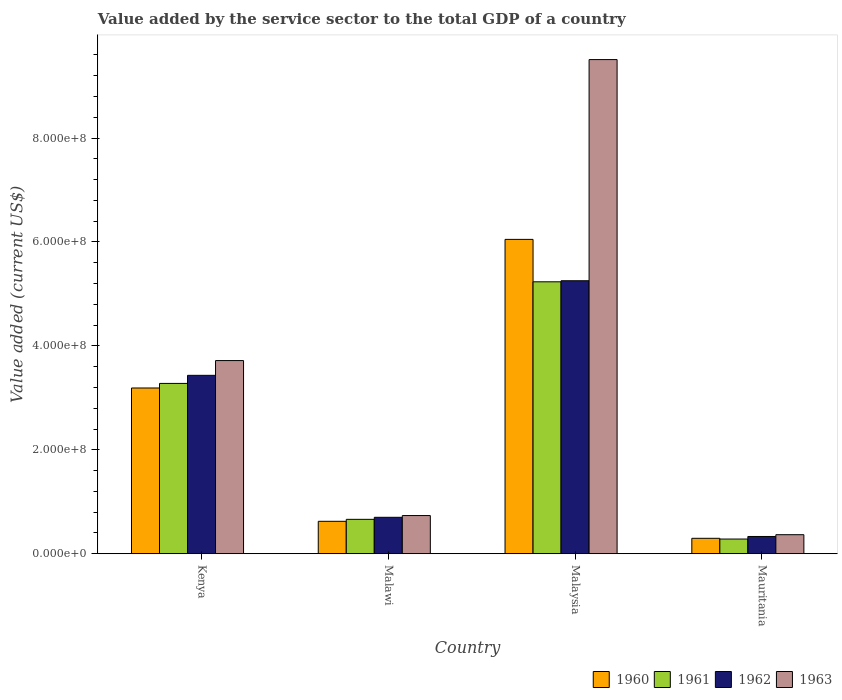How many groups of bars are there?
Your answer should be compact. 4. What is the label of the 3rd group of bars from the left?
Keep it short and to the point. Malaysia. In how many cases, is the number of bars for a given country not equal to the number of legend labels?
Provide a short and direct response. 0. What is the value added by the service sector to the total GDP in 1960 in Kenya?
Offer a terse response. 3.19e+08. Across all countries, what is the maximum value added by the service sector to the total GDP in 1961?
Your response must be concise. 5.23e+08. Across all countries, what is the minimum value added by the service sector to the total GDP in 1963?
Provide a short and direct response. 3.67e+07. In which country was the value added by the service sector to the total GDP in 1963 maximum?
Keep it short and to the point. Malaysia. In which country was the value added by the service sector to the total GDP in 1962 minimum?
Offer a terse response. Mauritania. What is the total value added by the service sector to the total GDP in 1963 in the graph?
Keep it short and to the point. 1.43e+09. What is the difference between the value added by the service sector to the total GDP in 1961 in Malawi and that in Mauritania?
Provide a short and direct response. 3.79e+07. What is the difference between the value added by the service sector to the total GDP in 1963 in Malawi and the value added by the service sector to the total GDP in 1960 in Kenya?
Provide a succinct answer. -2.46e+08. What is the average value added by the service sector to the total GDP in 1962 per country?
Offer a very short reply. 2.43e+08. What is the difference between the value added by the service sector to the total GDP of/in 1961 and value added by the service sector to the total GDP of/in 1960 in Malawi?
Provide a short and direct response. 3.78e+06. What is the ratio of the value added by the service sector to the total GDP in 1963 in Kenya to that in Malaysia?
Provide a short and direct response. 0.39. Is the difference between the value added by the service sector to the total GDP in 1961 in Kenya and Malawi greater than the difference between the value added by the service sector to the total GDP in 1960 in Kenya and Malawi?
Make the answer very short. Yes. What is the difference between the highest and the second highest value added by the service sector to the total GDP in 1963?
Provide a short and direct response. 5.79e+08. What is the difference between the highest and the lowest value added by the service sector to the total GDP in 1963?
Offer a very short reply. 9.14e+08. In how many countries, is the value added by the service sector to the total GDP in 1962 greater than the average value added by the service sector to the total GDP in 1962 taken over all countries?
Offer a terse response. 2. Is the sum of the value added by the service sector to the total GDP in 1961 in Malawi and Malaysia greater than the maximum value added by the service sector to the total GDP in 1963 across all countries?
Offer a terse response. No. Is it the case that in every country, the sum of the value added by the service sector to the total GDP in 1962 and value added by the service sector to the total GDP in 1960 is greater than the sum of value added by the service sector to the total GDP in 1961 and value added by the service sector to the total GDP in 1963?
Provide a short and direct response. No. What does the 2nd bar from the right in Mauritania represents?
Keep it short and to the point. 1962. Is it the case that in every country, the sum of the value added by the service sector to the total GDP in 1960 and value added by the service sector to the total GDP in 1962 is greater than the value added by the service sector to the total GDP in 1961?
Provide a short and direct response. Yes. What is the difference between two consecutive major ticks on the Y-axis?
Your response must be concise. 2.00e+08. Are the values on the major ticks of Y-axis written in scientific E-notation?
Give a very brief answer. Yes. How many legend labels are there?
Your answer should be very brief. 4. How are the legend labels stacked?
Make the answer very short. Horizontal. What is the title of the graph?
Your response must be concise. Value added by the service sector to the total GDP of a country. Does "2014" appear as one of the legend labels in the graph?
Your response must be concise. No. What is the label or title of the Y-axis?
Ensure brevity in your answer.  Value added (current US$). What is the Value added (current US$) of 1960 in Kenya?
Give a very brief answer. 3.19e+08. What is the Value added (current US$) in 1961 in Kenya?
Provide a short and direct response. 3.28e+08. What is the Value added (current US$) in 1962 in Kenya?
Ensure brevity in your answer.  3.43e+08. What is the Value added (current US$) in 1963 in Kenya?
Your response must be concise. 3.72e+08. What is the Value added (current US$) of 1960 in Malawi?
Offer a very short reply. 6.24e+07. What is the Value added (current US$) in 1961 in Malawi?
Ensure brevity in your answer.  6.62e+07. What is the Value added (current US$) of 1962 in Malawi?
Make the answer very short. 7.01e+07. What is the Value added (current US$) in 1963 in Malawi?
Ensure brevity in your answer.  7.35e+07. What is the Value added (current US$) in 1960 in Malaysia?
Make the answer very short. 6.05e+08. What is the Value added (current US$) of 1961 in Malaysia?
Your answer should be compact. 5.23e+08. What is the Value added (current US$) of 1962 in Malaysia?
Make the answer very short. 5.25e+08. What is the Value added (current US$) in 1963 in Malaysia?
Provide a succinct answer. 9.51e+08. What is the Value added (current US$) in 1960 in Mauritania?
Keep it short and to the point. 2.97e+07. What is the Value added (current US$) in 1961 in Mauritania?
Give a very brief answer. 2.83e+07. What is the Value added (current US$) in 1962 in Mauritania?
Provide a succinct answer. 3.32e+07. What is the Value added (current US$) in 1963 in Mauritania?
Give a very brief answer. 3.67e+07. Across all countries, what is the maximum Value added (current US$) of 1960?
Your answer should be compact. 6.05e+08. Across all countries, what is the maximum Value added (current US$) of 1961?
Make the answer very short. 5.23e+08. Across all countries, what is the maximum Value added (current US$) of 1962?
Offer a terse response. 5.25e+08. Across all countries, what is the maximum Value added (current US$) in 1963?
Make the answer very short. 9.51e+08. Across all countries, what is the minimum Value added (current US$) of 1960?
Your response must be concise. 2.97e+07. Across all countries, what is the minimum Value added (current US$) of 1961?
Your answer should be compact. 2.83e+07. Across all countries, what is the minimum Value added (current US$) in 1962?
Provide a succinct answer. 3.32e+07. Across all countries, what is the minimum Value added (current US$) in 1963?
Your response must be concise. 3.67e+07. What is the total Value added (current US$) of 1960 in the graph?
Provide a short and direct response. 1.02e+09. What is the total Value added (current US$) in 1961 in the graph?
Make the answer very short. 9.46e+08. What is the total Value added (current US$) in 1962 in the graph?
Offer a very short reply. 9.72e+08. What is the total Value added (current US$) of 1963 in the graph?
Keep it short and to the point. 1.43e+09. What is the difference between the Value added (current US$) of 1960 in Kenya and that in Malawi?
Provide a short and direct response. 2.57e+08. What is the difference between the Value added (current US$) of 1961 in Kenya and that in Malawi?
Provide a succinct answer. 2.62e+08. What is the difference between the Value added (current US$) of 1962 in Kenya and that in Malawi?
Provide a short and direct response. 2.73e+08. What is the difference between the Value added (current US$) in 1963 in Kenya and that in Malawi?
Provide a short and direct response. 2.98e+08. What is the difference between the Value added (current US$) in 1960 in Kenya and that in Malaysia?
Make the answer very short. -2.86e+08. What is the difference between the Value added (current US$) of 1961 in Kenya and that in Malaysia?
Offer a terse response. -1.96e+08. What is the difference between the Value added (current US$) in 1962 in Kenya and that in Malaysia?
Ensure brevity in your answer.  -1.82e+08. What is the difference between the Value added (current US$) of 1963 in Kenya and that in Malaysia?
Ensure brevity in your answer.  -5.79e+08. What is the difference between the Value added (current US$) of 1960 in Kenya and that in Mauritania?
Ensure brevity in your answer.  2.89e+08. What is the difference between the Value added (current US$) of 1961 in Kenya and that in Mauritania?
Your response must be concise. 3.00e+08. What is the difference between the Value added (current US$) in 1962 in Kenya and that in Mauritania?
Your answer should be very brief. 3.10e+08. What is the difference between the Value added (current US$) in 1963 in Kenya and that in Mauritania?
Give a very brief answer. 3.35e+08. What is the difference between the Value added (current US$) in 1960 in Malawi and that in Malaysia?
Give a very brief answer. -5.43e+08. What is the difference between the Value added (current US$) of 1961 in Malawi and that in Malaysia?
Make the answer very short. -4.57e+08. What is the difference between the Value added (current US$) of 1962 in Malawi and that in Malaysia?
Provide a short and direct response. -4.55e+08. What is the difference between the Value added (current US$) in 1963 in Malawi and that in Malaysia?
Your answer should be compact. -8.78e+08. What is the difference between the Value added (current US$) of 1960 in Malawi and that in Mauritania?
Keep it short and to the point. 3.27e+07. What is the difference between the Value added (current US$) in 1961 in Malawi and that in Mauritania?
Provide a succinct answer. 3.79e+07. What is the difference between the Value added (current US$) of 1962 in Malawi and that in Mauritania?
Your response must be concise. 3.69e+07. What is the difference between the Value added (current US$) in 1963 in Malawi and that in Mauritania?
Your answer should be compact. 3.68e+07. What is the difference between the Value added (current US$) in 1960 in Malaysia and that in Mauritania?
Give a very brief answer. 5.75e+08. What is the difference between the Value added (current US$) in 1961 in Malaysia and that in Mauritania?
Your answer should be compact. 4.95e+08. What is the difference between the Value added (current US$) of 1962 in Malaysia and that in Mauritania?
Your response must be concise. 4.92e+08. What is the difference between the Value added (current US$) in 1963 in Malaysia and that in Mauritania?
Keep it short and to the point. 9.14e+08. What is the difference between the Value added (current US$) in 1960 in Kenya and the Value added (current US$) in 1961 in Malawi?
Make the answer very short. 2.53e+08. What is the difference between the Value added (current US$) of 1960 in Kenya and the Value added (current US$) of 1962 in Malawi?
Provide a short and direct response. 2.49e+08. What is the difference between the Value added (current US$) of 1960 in Kenya and the Value added (current US$) of 1963 in Malawi?
Give a very brief answer. 2.46e+08. What is the difference between the Value added (current US$) in 1961 in Kenya and the Value added (current US$) in 1962 in Malawi?
Your answer should be very brief. 2.58e+08. What is the difference between the Value added (current US$) in 1961 in Kenya and the Value added (current US$) in 1963 in Malawi?
Make the answer very short. 2.54e+08. What is the difference between the Value added (current US$) in 1962 in Kenya and the Value added (current US$) in 1963 in Malawi?
Provide a succinct answer. 2.70e+08. What is the difference between the Value added (current US$) in 1960 in Kenya and the Value added (current US$) in 1961 in Malaysia?
Give a very brief answer. -2.04e+08. What is the difference between the Value added (current US$) of 1960 in Kenya and the Value added (current US$) of 1962 in Malaysia?
Provide a succinct answer. -2.06e+08. What is the difference between the Value added (current US$) of 1960 in Kenya and the Value added (current US$) of 1963 in Malaysia?
Give a very brief answer. -6.32e+08. What is the difference between the Value added (current US$) of 1961 in Kenya and the Value added (current US$) of 1962 in Malaysia?
Provide a short and direct response. -1.98e+08. What is the difference between the Value added (current US$) of 1961 in Kenya and the Value added (current US$) of 1963 in Malaysia?
Make the answer very short. -6.23e+08. What is the difference between the Value added (current US$) in 1962 in Kenya and the Value added (current US$) in 1963 in Malaysia?
Provide a short and direct response. -6.08e+08. What is the difference between the Value added (current US$) of 1960 in Kenya and the Value added (current US$) of 1961 in Mauritania?
Give a very brief answer. 2.91e+08. What is the difference between the Value added (current US$) in 1960 in Kenya and the Value added (current US$) in 1962 in Mauritania?
Keep it short and to the point. 2.86e+08. What is the difference between the Value added (current US$) of 1960 in Kenya and the Value added (current US$) of 1963 in Mauritania?
Your answer should be compact. 2.82e+08. What is the difference between the Value added (current US$) in 1961 in Kenya and the Value added (current US$) in 1962 in Mauritania?
Your answer should be compact. 2.95e+08. What is the difference between the Value added (current US$) in 1961 in Kenya and the Value added (current US$) in 1963 in Mauritania?
Keep it short and to the point. 2.91e+08. What is the difference between the Value added (current US$) of 1962 in Kenya and the Value added (current US$) of 1963 in Mauritania?
Ensure brevity in your answer.  3.07e+08. What is the difference between the Value added (current US$) of 1960 in Malawi and the Value added (current US$) of 1961 in Malaysia?
Provide a succinct answer. -4.61e+08. What is the difference between the Value added (current US$) in 1960 in Malawi and the Value added (current US$) in 1962 in Malaysia?
Provide a succinct answer. -4.63e+08. What is the difference between the Value added (current US$) in 1960 in Malawi and the Value added (current US$) in 1963 in Malaysia?
Provide a short and direct response. -8.89e+08. What is the difference between the Value added (current US$) of 1961 in Malawi and the Value added (current US$) of 1962 in Malaysia?
Offer a very short reply. -4.59e+08. What is the difference between the Value added (current US$) of 1961 in Malawi and the Value added (current US$) of 1963 in Malaysia?
Keep it short and to the point. -8.85e+08. What is the difference between the Value added (current US$) in 1962 in Malawi and the Value added (current US$) in 1963 in Malaysia?
Give a very brief answer. -8.81e+08. What is the difference between the Value added (current US$) in 1960 in Malawi and the Value added (current US$) in 1961 in Mauritania?
Provide a short and direct response. 3.41e+07. What is the difference between the Value added (current US$) of 1960 in Malawi and the Value added (current US$) of 1962 in Mauritania?
Keep it short and to the point. 2.92e+07. What is the difference between the Value added (current US$) of 1960 in Malawi and the Value added (current US$) of 1963 in Mauritania?
Offer a very short reply. 2.58e+07. What is the difference between the Value added (current US$) of 1961 in Malawi and the Value added (current US$) of 1962 in Mauritania?
Your answer should be very brief. 3.30e+07. What is the difference between the Value added (current US$) in 1961 in Malawi and the Value added (current US$) in 1963 in Mauritania?
Your answer should be compact. 2.96e+07. What is the difference between the Value added (current US$) in 1962 in Malawi and the Value added (current US$) in 1963 in Mauritania?
Provide a short and direct response. 3.35e+07. What is the difference between the Value added (current US$) in 1960 in Malaysia and the Value added (current US$) in 1961 in Mauritania?
Your answer should be very brief. 5.77e+08. What is the difference between the Value added (current US$) in 1960 in Malaysia and the Value added (current US$) in 1962 in Mauritania?
Keep it short and to the point. 5.72e+08. What is the difference between the Value added (current US$) in 1960 in Malaysia and the Value added (current US$) in 1963 in Mauritania?
Give a very brief answer. 5.68e+08. What is the difference between the Value added (current US$) of 1961 in Malaysia and the Value added (current US$) of 1962 in Mauritania?
Your response must be concise. 4.90e+08. What is the difference between the Value added (current US$) of 1961 in Malaysia and the Value added (current US$) of 1963 in Mauritania?
Your answer should be compact. 4.87e+08. What is the difference between the Value added (current US$) in 1962 in Malaysia and the Value added (current US$) in 1963 in Mauritania?
Make the answer very short. 4.89e+08. What is the average Value added (current US$) of 1960 per country?
Your response must be concise. 2.54e+08. What is the average Value added (current US$) in 1961 per country?
Your response must be concise. 2.36e+08. What is the average Value added (current US$) in 1962 per country?
Provide a short and direct response. 2.43e+08. What is the average Value added (current US$) of 1963 per country?
Provide a succinct answer. 3.58e+08. What is the difference between the Value added (current US$) of 1960 and Value added (current US$) of 1961 in Kenya?
Offer a terse response. -8.81e+06. What is the difference between the Value added (current US$) of 1960 and Value added (current US$) of 1962 in Kenya?
Your answer should be very brief. -2.43e+07. What is the difference between the Value added (current US$) in 1960 and Value added (current US$) in 1963 in Kenya?
Offer a very short reply. -5.28e+07. What is the difference between the Value added (current US$) of 1961 and Value added (current US$) of 1962 in Kenya?
Offer a terse response. -1.55e+07. What is the difference between the Value added (current US$) in 1961 and Value added (current US$) in 1963 in Kenya?
Offer a terse response. -4.40e+07. What is the difference between the Value added (current US$) of 1962 and Value added (current US$) of 1963 in Kenya?
Offer a terse response. -2.84e+07. What is the difference between the Value added (current US$) of 1960 and Value added (current US$) of 1961 in Malawi?
Ensure brevity in your answer.  -3.78e+06. What is the difference between the Value added (current US$) of 1960 and Value added (current US$) of 1962 in Malawi?
Make the answer very short. -7.70e+06. What is the difference between the Value added (current US$) in 1960 and Value added (current US$) in 1963 in Malawi?
Give a very brief answer. -1.11e+07. What is the difference between the Value added (current US$) of 1961 and Value added (current US$) of 1962 in Malawi?
Ensure brevity in your answer.  -3.92e+06. What is the difference between the Value added (current US$) of 1961 and Value added (current US$) of 1963 in Malawi?
Provide a succinct answer. -7.28e+06. What is the difference between the Value added (current US$) of 1962 and Value added (current US$) of 1963 in Malawi?
Your answer should be very brief. -3.36e+06. What is the difference between the Value added (current US$) in 1960 and Value added (current US$) in 1961 in Malaysia?
Your response must be concise. 8.16e+07. What is the difference between the Value added (current US$) in 1960 and Value added (current US$) in 1962 in Malaysia?
Your response must be concise. 7.96e+07. What is the difference between the Value added (current US$) in 1960 and Value added (current US$) in 1963 in Malaysia?
Your answer should be compact. -3.46e+08. What is the difference between the Value added (current US$) of 1961 and Value added (current US$) of 1962 in Malaysia?
Keep it short and to the point. -2.03e+06. What is the difference between the Value added (current US$) of 1961 and Value added (current US$) of 1963 in Malaysia?
Your answer should be compact. -4.28e+08. What is the difference between the Value added (current US$) of 1962 and Value added (current US$) of 1963 in Malaysia?
Provide a succinct answer. -4.26e+08. What is the difference between the Value added (current US$) in 1960 and Value added (current US$) in 1961 in Mauritania?
Make the answer very short. 1.42e+06. What is the difference between the Value added (current US$) of 1960 and Value added (current US$) of 1962 in Mauritania?
Ensure brevity in your answer.  -3.51e+06. What is the difference between the Value added (current US$) in 1960 and Value added (current US$) in 1963 in Mauritania?
Ensure brevity in your answer.  -6.94e+06. What is the difference between the Value added (current US$) in 1961 and Value added (current US$) in 1962 in Mauritania?
Provide a succinct answer. -4.93e+06. What is the difference between the Value added (current US$) in 1961 and Value added (current US$) in 1963 in Mauritania?
Make the answer very short. -8.35e+06. What is the difference between the Value added (current US$) in 1962 and Value added (current US$) in 1963 in Mauritania?
Offer a very short reply. -3.42e+06. What is the ratio of the Value added (current US$) in 1960 in Kenya to that in Malawi?
Make the answer very short. 5.11. What is the ratio of the Value added (current US$) in 1961 in Kenya to that in Malawi?
Provide a succinct answer. 4.95. What is the ratio of the Value added (current US$) in 1962 in Kenya to that in Malawi?
Ensure brevity in your answer.  4.89. What is the ratio of the Value added (current US$) in 1963 in Kenya to that in Malawi?
Make the answer very short. 5.06. What is the ratio of the Value added (current US$) of 1960 in Kenya to that in Malaysia?
Ensure brevity in your answer.  0.53. What is the ratio of the Value added (current US$) of 1961 in Kenya to that in Malaysia?
Your answer should be very brief. 0.63. What is the ratio of the Value added (current US$) in 1962 in Kenya to that in Malaysia?
Keep it short and to the point. 0.65. What is the ratio of the Value added (current US$) of 1963 in Kenya to that in Malaysia?
Offer a very short reply. 0.39. What is the ratio of the Value added (current US$) of 1960 in Kenya to that in Mauritania?
Provide a succinct answer. 10.73. What is the ratio of the Value added (current US$) in 1961 in Kenya to that in Mauritania?
Provide a short and direct response. 11.58. What is the ratio of the Value added (current US$) in 1962 in Kenya to that in Mauritania?
Your answer should be very brief. 10.33. What is the ratio of the Value added (current US$) in 1963 in Kenya to that in Mauritania?
Offer a very short reply. 10.14. What is the ratio of the Value added (current US$) of 1960 in Malawi to that in Malaysia?
Ensure brevity in your answer.  0.1. What is the ratio of the Value added (current US$) of 1961 in Malawi to that in Malaysia?
Make the answer very short. 0.13. What is the ratio of the Value added (current US$) in 1962 in Malawi to that in Malaysia?
Give a very brief answer. 0.13. What is the ratio of the Value added (current US$) in 1963 in Malawi to that in Malaysia?
Your response must be concise. 0.08. What is the ratio of the Value added (current US$) in 1960 in Malawi to that in Mauritania?
Make the answer very short. 2.1. What is the ratio of the Value added (current US$) in 1961 in Malawi to that in Mauritania?
Ensure brevity in your answer.  2.34. What is the ratio of the Value added (current US$) of 1962 in Malawi to that in Mauritania?
Give a very brief answer. 2.11. What is the ratio of the Value added (current US$) of 1963 in Malawi to that in Mauritania?
Keep it short and to the point. 2.01. What is the ratio of the Value added (current US$) in 1960 in Malaysia to that in Mauritania?
Offer a very short reply. 20.36. What is the ratio of the Value added (current US$) of 1961 in Malaysia to that in Mauritania?
Offer a very short reply. 18.49. What is the ratio of the Value added (current US$) in 1962 in Malaysia to that in Mauritania?
Your answer should be very brief. 15.81. What is the ratio of the Value added (current US$) of 1963 in Malaysia to that in Mauritania?
Ensure brevity in your answer.  25.94. What is the difference between the highest and the second highest Value added (current US$) of 1960?
Your answer should be very brief. 2.86e+08. What is the difference between the highest and the second highest Value added (current US$) of 1961?
Your response must be concise. 1.96e+08. What is the difference between the highest and the second highest Value added (current US$) of 1962?
Ensure brevity in your answer.  1.82e+08. What is the difference between the highest and the second highest Value added (current US$) of 1963?
Offer a terse response. 5.79e+08. What is the difference between the highest and the lowest Value added (current US$) in 1960?
Keep it short and to the point. 5.75e+08. What is the difference between the highest and the lowest Value added (current US$) in 1961?
Your response must be concise. 4.95e+08. What is the difference between the highest and the lowest Value added (current US$) in 1962?
Provide a short and direct response. 4.92e+08. What is the difference between the highest and the lowest Value added (current US$) of 1963?
Your answer should be compact. 9.14e+08. 